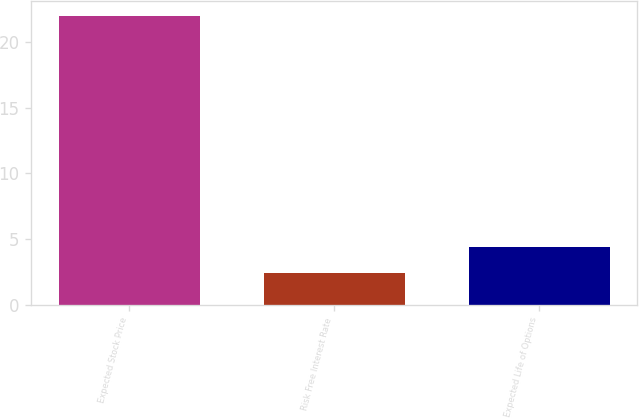Convert chart to OTSL. <chart><loc_0><loc_0><loc_500><loc_500><bar_chart><fcel>Expected Stock Price<fcel>Risk Free Interest Rate<fcel>Expected Life of Options<nl><fcel>22<fcel>2.4<fcel>4.4<nl></chart> 